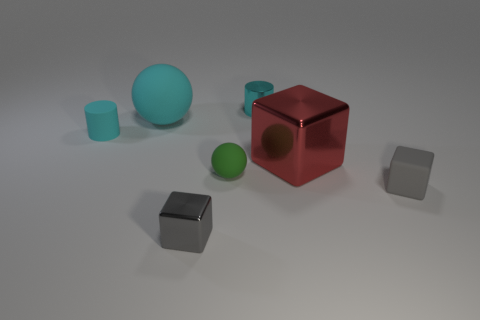How many large red metallic objects are behind the big ball?
Your response must be concise. 0. Is there a tiny blue shiny object?
Your answer should be compact. No. The matte sphere to the left of the cube left of the small cylinder behind the small rubber cylinder is what color?
Provide a short and direct response. Cyan. Is there a object that is on the right side of the gray thing to the left of the red metal block?
Your answer should be very brief. Yes. There is a small thing that is to the left of the cyan sphere; is it the same color as the tiny thing that is behind the large cyan ball?
Your response must be concise. Yes. How many gray metallic objects are the same size as the red shiny thing?
Give a very brief answer. 0. Do the gray cube that is on the right side of the green sphere and the cyan matte ball have the same size?
Offer a terse response. No. There is a large cyan object; what shape is it?
Your answer should be very brief. Sphere. The rubber cylinder that is the same color as the big ball is what size?
Your answer should be very brief. Small. Do the tiny cyan cylinder on the right side of the large ball and the red object have the same material?
Offer a terse response. Yes. 